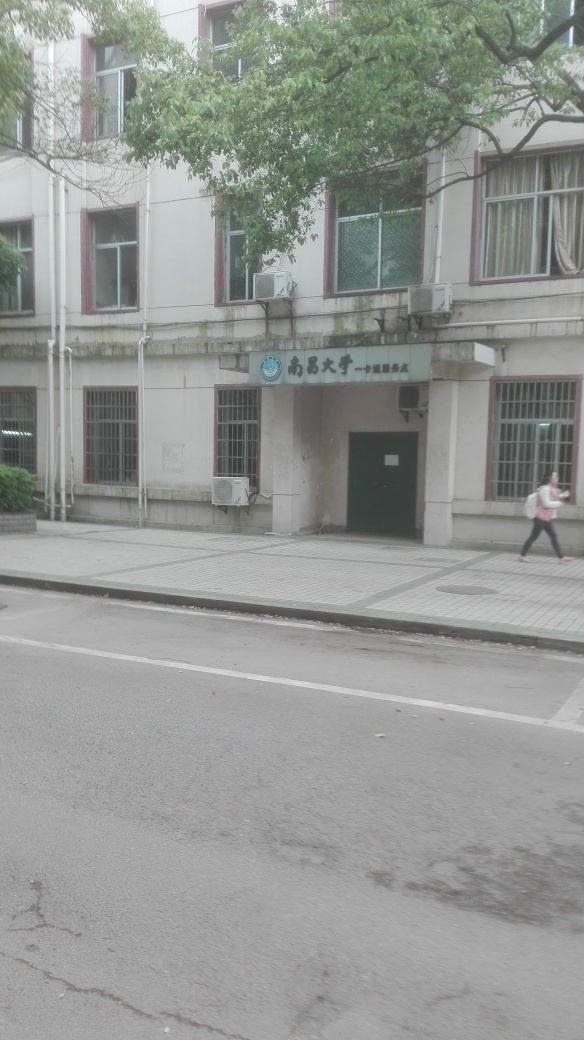Does the image show any signs of the area being busy or populated? There is one individual on the footpath, suggesting some pedestrian activity, but overall the area depicted in the image doesn't seem very crowded or busy. The absence of vehicles and additional pedestrians might indicate that the photo was taken during a less active time of day or in a less frequented location. 